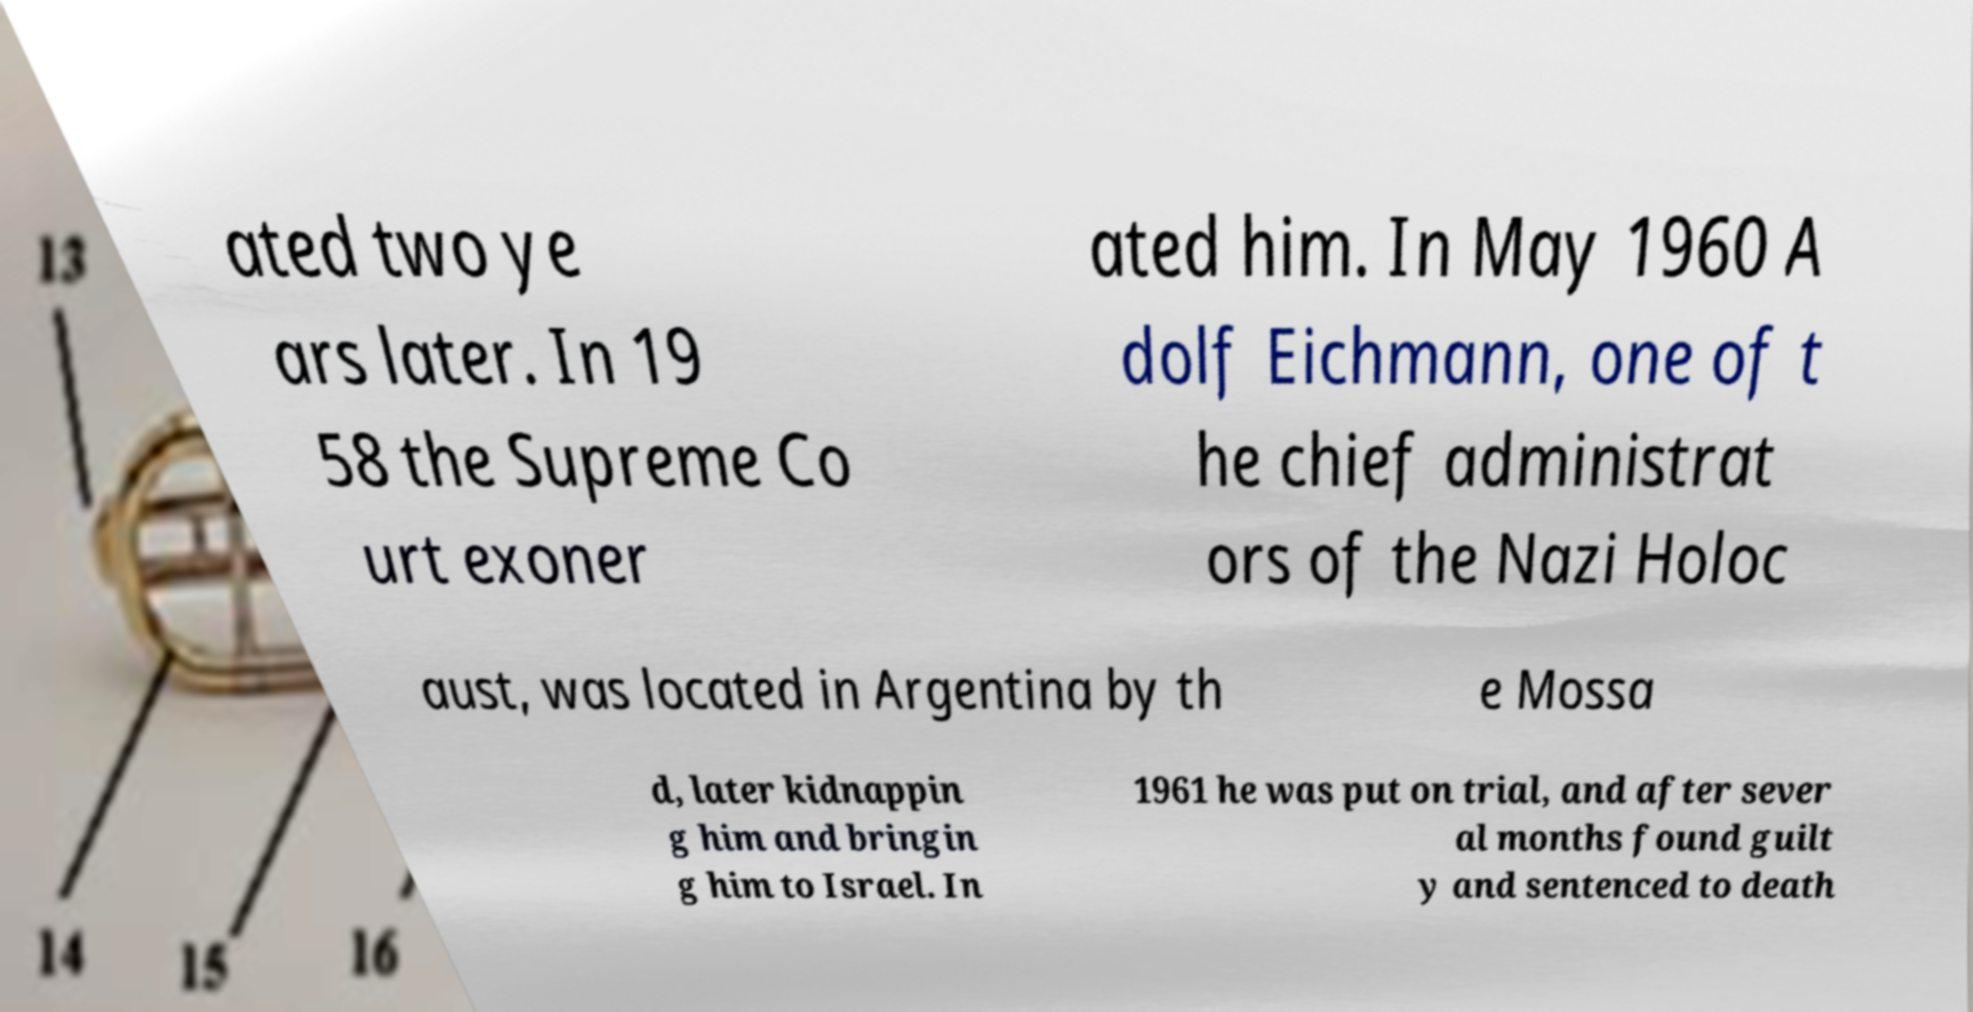Can you read and provide the text displayed in the image?This photo seems to have some interesting text. Can you extract and type it out for me? ated two ye ars later. In 19 58 the Supreme Co urt exoner ated him. In May 1960 A dolf Eichmann, one of t he chief administrat ors of the Nazi Holoc aust, was located in Argentina by th e Mossa d, later kidnappin g him and bringin g him to Israel. In 1961 he was put on trial, and after sever al months found guilt y and sentenced to death 